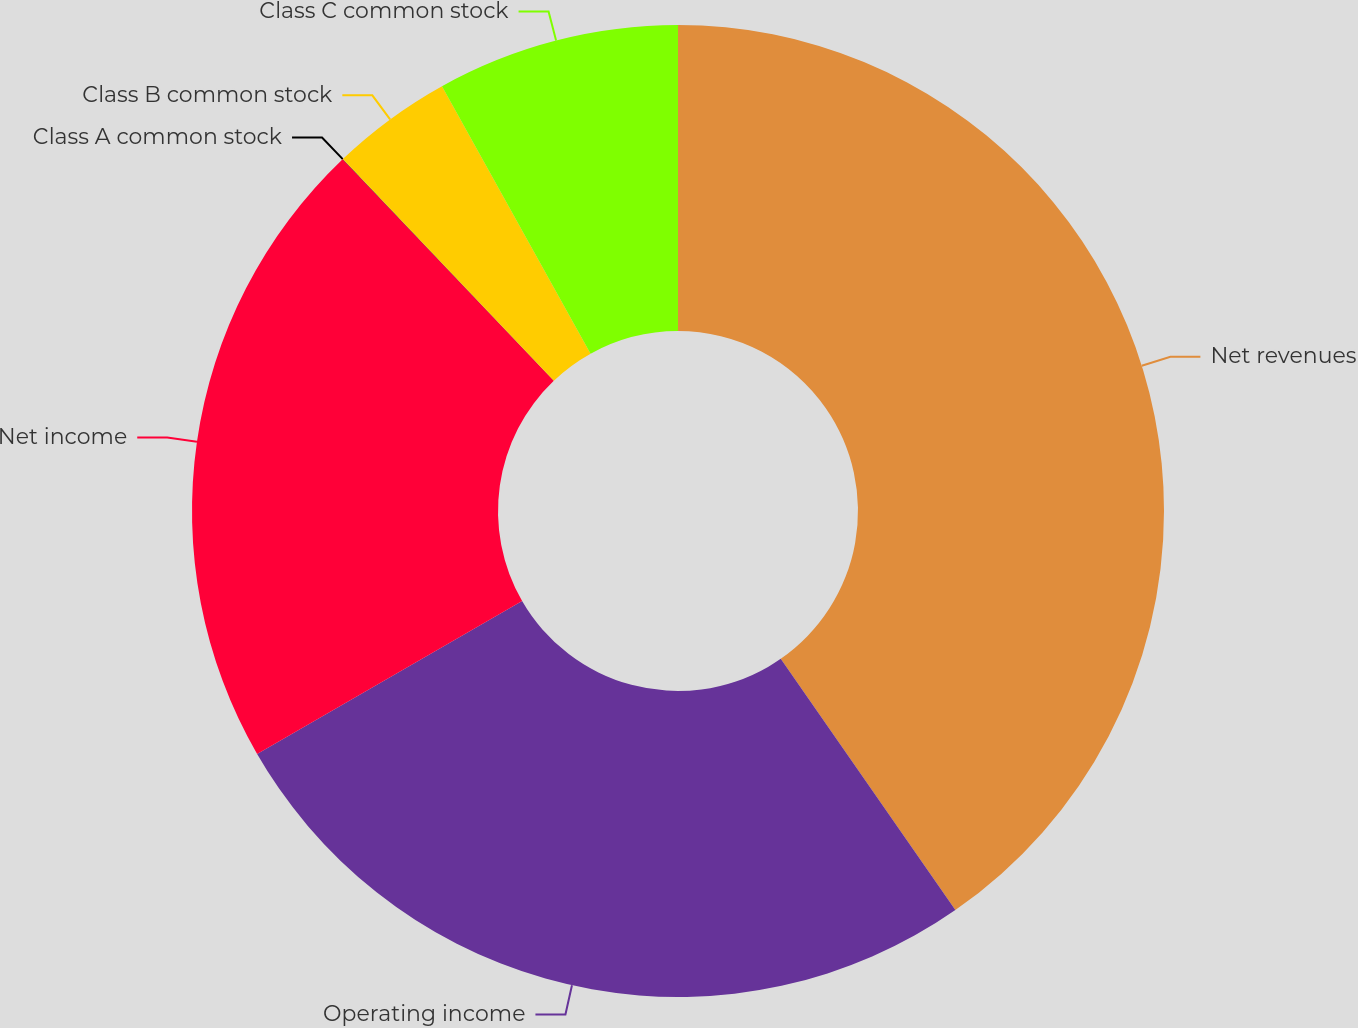<chart> <loc_0><loc_0><loc_500><loc_500><pie_chart><fcel>Net revenues<fcel>Operating income<fcel>Net income<fcel>Class A common stock<fcel>Class B common stock<fcel>Class C common stock<nl><fcel>40.33%<fcel>26.33%<fcel>21.21%<fcel>0.01%<fcel>4.04%<fcel>8.07%<nl></chart> 